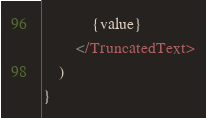Convert code to text. <code><loc_0><loc_0><loc_500><loc_500><_TypeScript_>            {value}
        </TruncatedText>
    )
}
</code> 